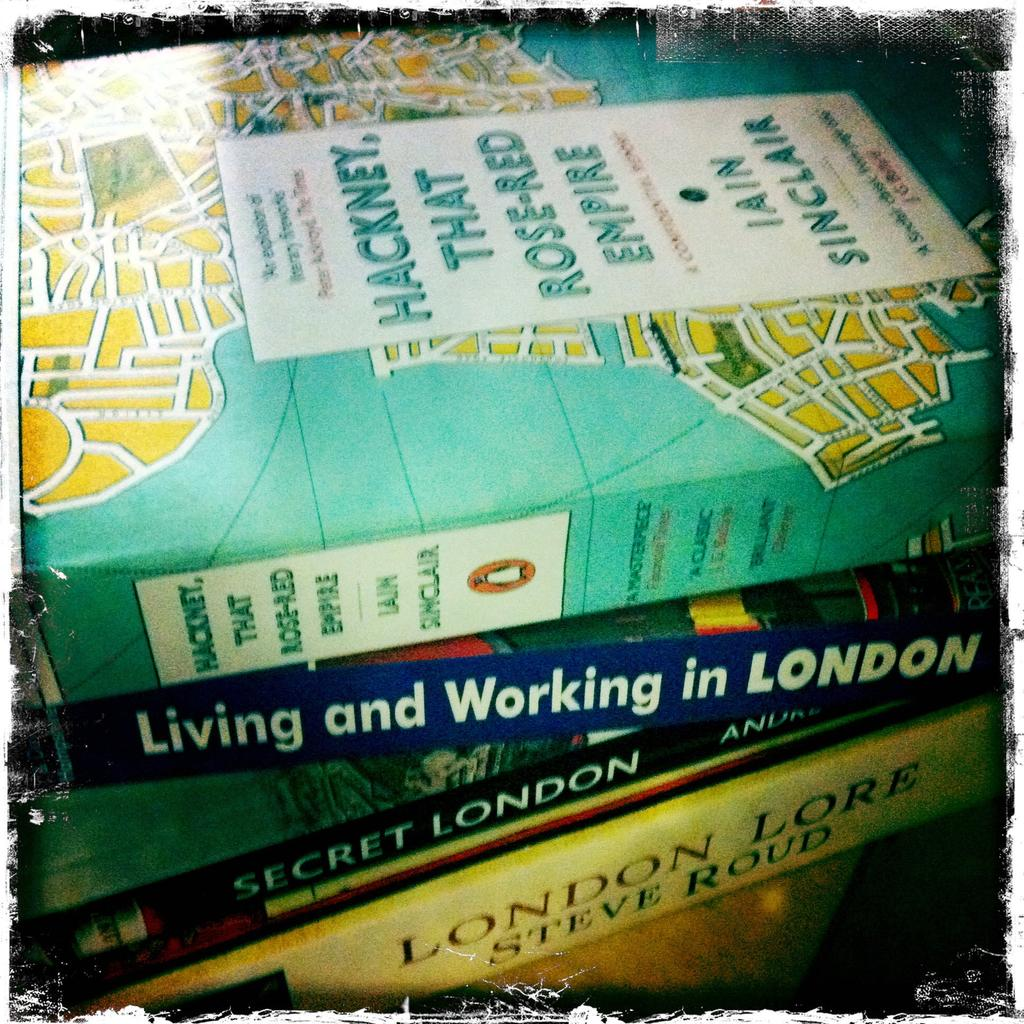<image>
Give a short and clear explanation of the subsequent image. A pile of books, one of which is called Living and Working in London. 